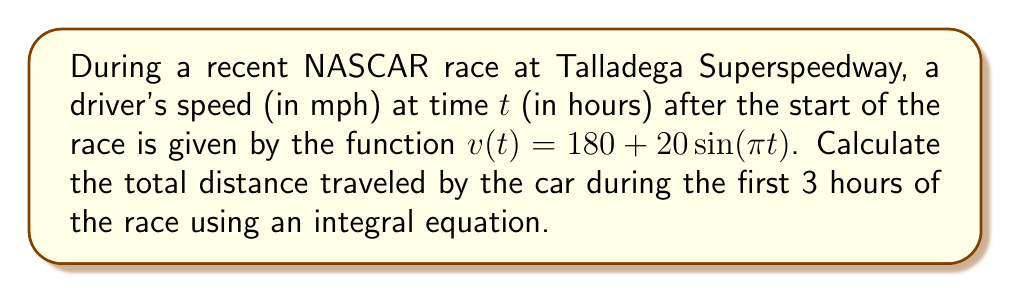Provide a solution to this math problem. To solve this problem, we need to follow these steps:

1) The distance traveled is the integral of velocity over time. We can express this as:

   $$d = \int_0^3 v(t) dt$$

2) Substitute the given velocity function:

   $$d = \int_0^3 (180 + 20\sin(\pi t)) dt$$

3) Separate the integral:

   $$d = \int_0^3 180 dt + \int_0^3 20\sin(\pi t) dt$$

4) Evaluate the first integral:

   $$180t \Big|_0^3 = 180 \cdot 3 - 180 \cdot 0 = 540$$

5) For the second integral, use the substitution $u = \pi t$, $du = \pi dt$, $dt = \frac{1}{\pi} du$:

   $$\frac{20}{\pi} \int_0^{3\pi} \sin(u) du$$

6) Evaluate this integral:

   $$\frac{20}{\pi} [-\cos(u)]_0^{3\pi} = \frac{20}{\pi} [-\cos(3\pi) + \cos(0)] = \frac{20}{\pi} [1 + 1] = \frac{40}{\pi}$$

7) Sum the results from steps 4 and 6:

   $$d = 540 + \frac{40}{\pi}$$

8) This distance is in miles, as the original velocity was in mph.
Answer: $540 + \frac{40}{\pi}$ miles 